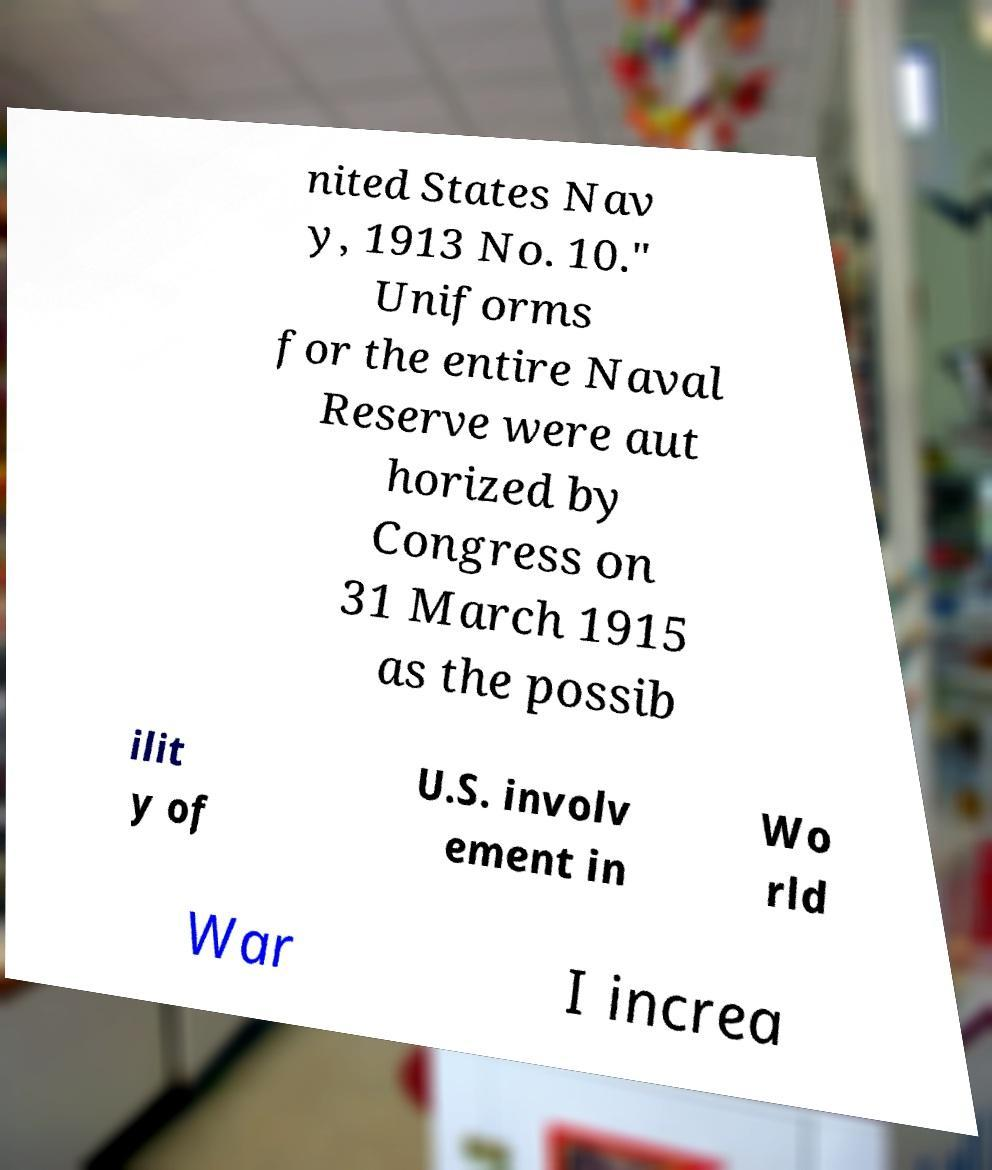Please read and relay the text visible in this image. What does it say? nited States Nav y, 1913 No. 10." Uniforms for the entire Naval Reserve were aut horized by Congress on 31 March 1915 as the possib ilit y of U.S. involv ement in Wo rld War I increa 